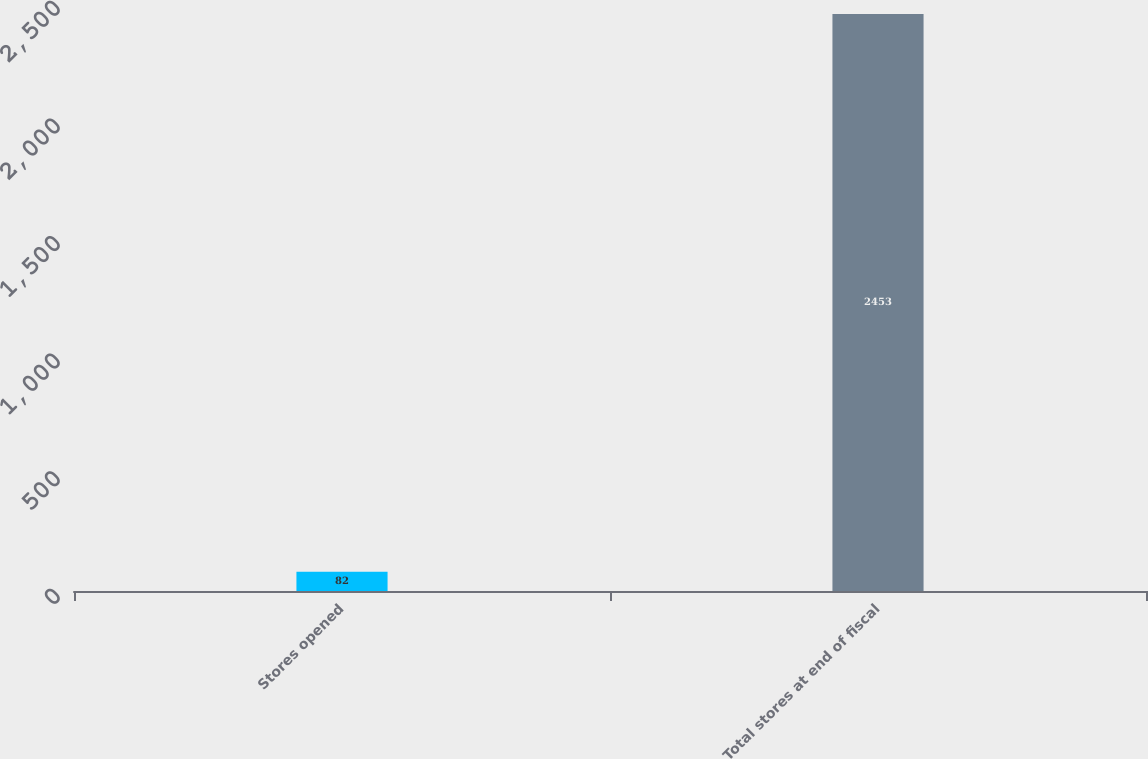<chart> <loc_0><loc_0><loc_500><loc_500><bar_chart><fcel>Stores opened<fcel>Total stores at end of fiscal<nl><fcel>82<fcel>2453<nl></chart> 